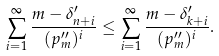<formula> <loc_0><loc_0><loc_500><loc_500>\sum _ { i = 1 } ^ { \infty } \frac { m - \delta ^ { \prime } _ { n + i } } { ( p _ { m } ^ { \prime \prime } ) ^ { i } } \leq \sum _ { i = 1 } ^ { \infty } \frac { m - \delta ^ { \prime } _ { k + i } } { ( p _ { m } ^ { \prime \prime } ) ^ { i } } .</formula> 